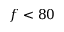Convert formula to latex. <formula><loc_0><loc_0><loc_500><loc_500>f < 8 0</formula> 